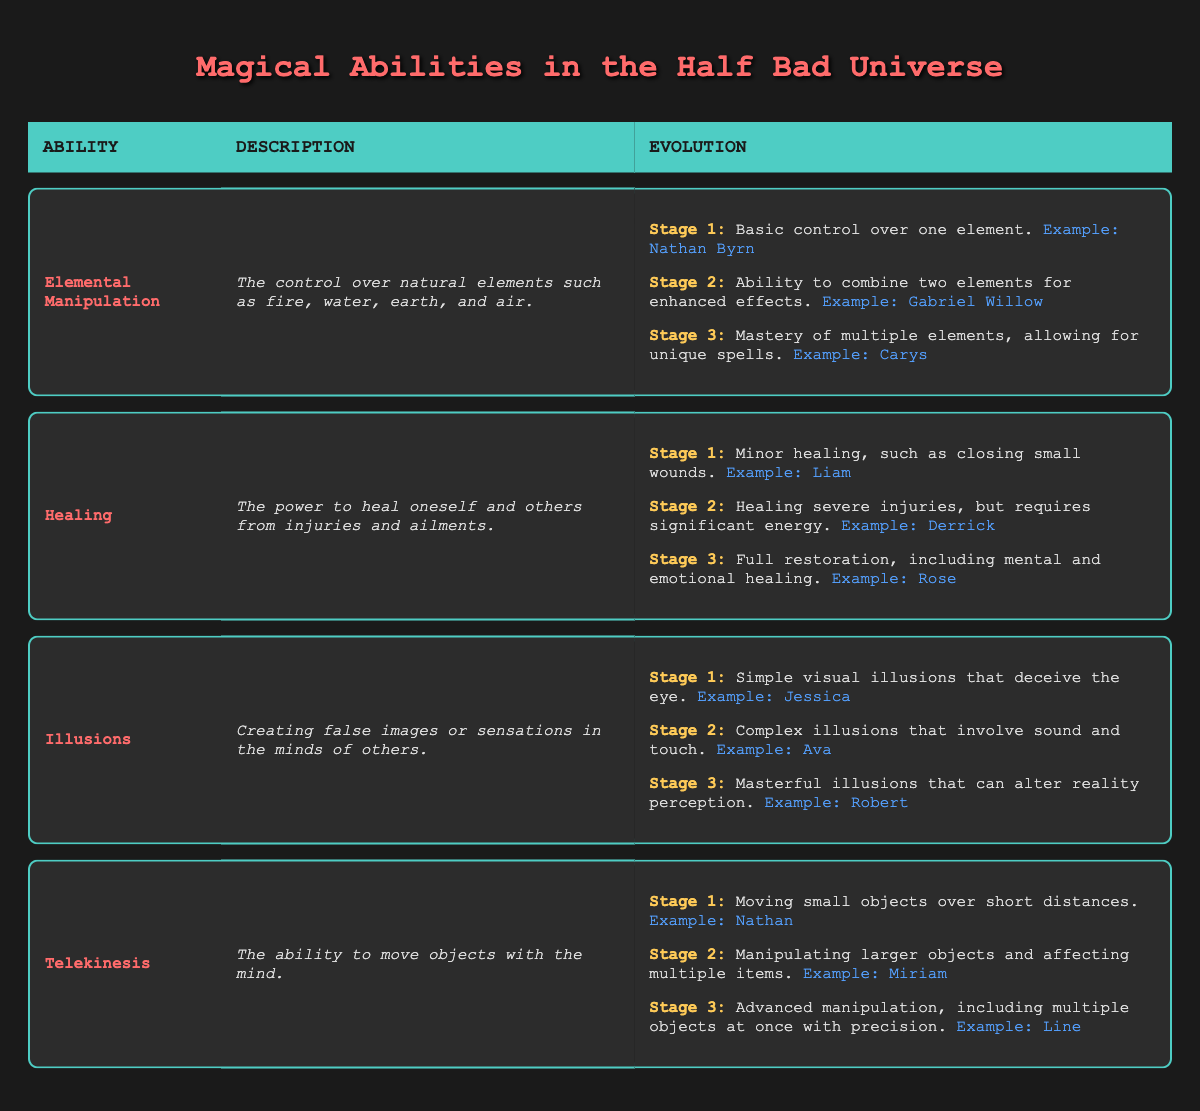What is the ability that involves control over fire, water, earth, and air? The table lists "Elemental Manipulation" as the ability that involves control over natural elements such as fire, water, earth, and air.
Answer: Elemental Manipulation Who is an example character for stage 3 of the Healing ability? The table specifies that the example character for stage 3 of Healing, which is full restoration including mental and emotional healing, is "Rose."
Answer: Rose Which ability has complex illusions involving sound and touch at stage 2? According to the table, the ability "Illusions" has complex illusions involving sound and touch at stage 2, and the example character for that stage is "Ava."
Answer: Illusions Does Nathan Byrn demonstrate mastery over multiple elements? The table indicates that Nathan Byrn is an example character for stage 1 of "Elemental Manipulation," which is basic control over one element, not mastery. Thus, the answer is no.
Answer: No How many characters are examples for stage 1 in the different abilities? The table lists 4 abilities, and each has one example character for stage 1: Nathan Byrn for Elemental Manipulation, Liam for Healing, Jessica for Illusions, and Nathan for Telekinesis. Thus, there are a total of 4 characters.
Answer: 4 At which stage does Carys appear in the Elemental Manipulation evolution? Carys is mentioned as the example character under stage 3 of "Elemental Manipulation," which refers to mastery of multiple elements.
Answer: Stage 3 Is "Telekinesis" described as the ability to heal injuries? The table describes "Telekinesis" as the ability to move objects with the mind, while the ability to heal injuries is described under "Healing." Therefore, the answer is no.
Answer: No What is the progression from stage 1 to stage 3 for Healing in terms of severity? The progression shows that stage 1 is minor healing, such as closing small wounds; stage 2 is healing severe injuries but requires significant energy; and stage 3 is full restoration, including mental and emotional healing.
Answer: From minor to full restoration Which ability includes advanced manipulation of multiple objects at once? The table specifies that "Telekinesis" includes advanced manipulation, allowing for the movement of multiple objects at once with precision at stage 3, with the example character being “Line.”
Answer: Telekinesis 